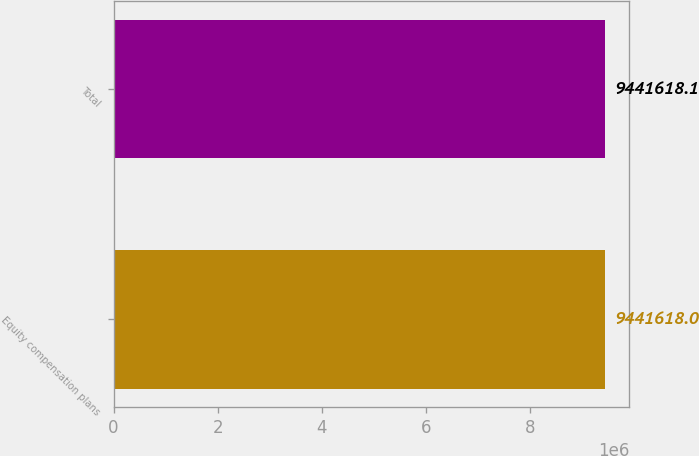Convert chart to OTSL. <chart><loc_0><loc_0><loc_500><loc_500><bar_chart><fcel>Equity compensation plans<fcel>Total<nl><fcel>9.44162e+06<fcel>9.44162e+06<nl></chart> 